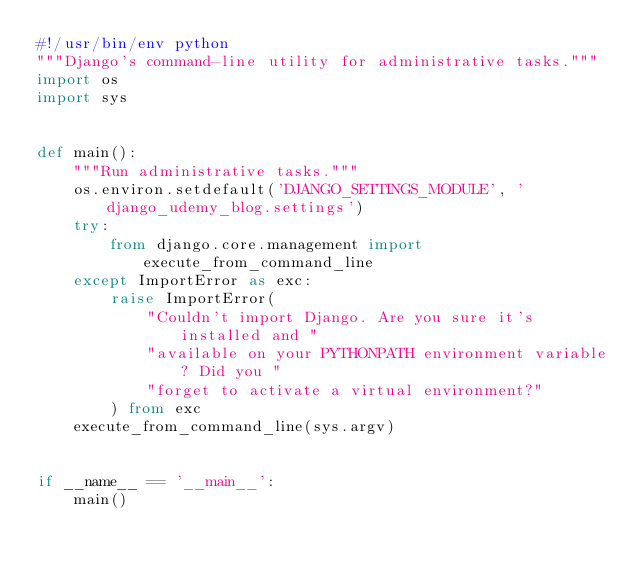<code> <loc_0><loc_0><loc_500><loc_500><_Python_>#!/usr/bin/env python
"""Django's command-line utility for administrative tasks."""
import os
import sys


def main():
    """Run administrative tasks."""
    os.environ.setdefault('DJANGO_SETTINGS_MODULE', 'django_udemy_blog.settings')
    try:
        from django.core.management import execute_from_command_line
    except ImportError as exc:
        raise ImportError(
            "Couldn't import Django. Are you sure it's installed and "
            "available on your PYTHONPATH environment variable? Did you "
            "forget to activate a virtual environment?"
        ) from exc
    execute_from_command_line(sys.argv)


if __name__ == '__main__':
    main()
</code> 